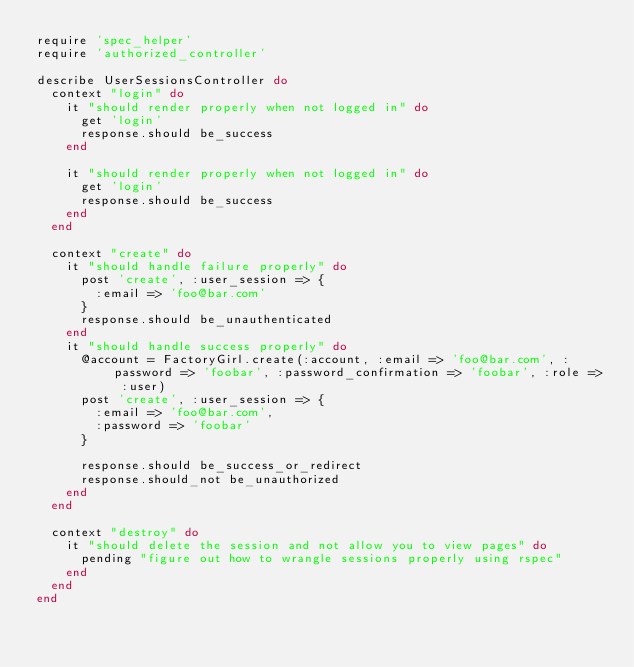<code> <loc_0><loc_0><loc_500><loc_500><_Ruby_>require 'spec_helper'
require 'authorized_controller'

describe UserSessionsController do
  context "login" do
    it "should render properly when not logged in" do
      get 'login'
      response.should be_success
    end

    it "should render properly when not logged in" do
      get 'login'
      response.should be_success
    end
  end

  context "create" do
    it "should handle failure properly" do
      post 'create', :user_session => {
        :email => 'foo@bar.com'
      }
      response.should be_unauthenticated
    end
    it "should handle success properly" do
      @account = FactoryGirl.create(:account, :email => 'foo@bar.com', :password => 'foobar', :password_confirmation => 'foobar', :role => :user)
      post 'create', :user_session => {
        :email => 'foo@bar.com',
        :password => 'foobar'
      }

      response.should be_success_or_redirect
      response.should_not be_unauthorized
    end
  end

  context "destroy" do
    it "should delete the session and not allow you to view pages" do
      pending "figure out how to wrangle sessions properly using rspec"
    end
  end
end
</code> 